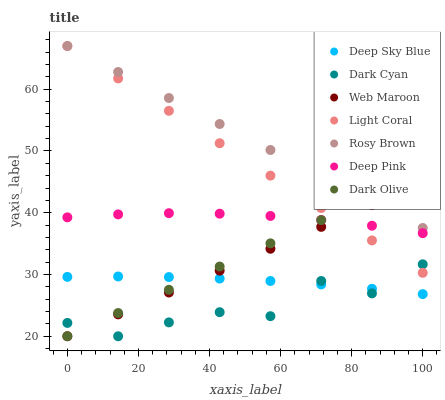Does Dark Cyan have the minimum area under the curve?
Answer yes or no. Yes. Does Rosy Brown have the maximum area under the curve?
Answer yes or no. Yes. Does Dark Olive have the minimum area under the curve?
Answer yes or no. No. Does Dark Olive have the maximum area under the curve?
Answer yes or no. No. Is Rosy Brown the smoothest?
Answer yes or no. Yes. Is Dark Cyan the roughest?
Answer yes or no. Yes. Is Dark Olive the smoothest?
Answer yes or no. No. Is Dark Olive the roughest?
Answer yes or no. No. Does Dark Olive have the lowest value?
Answer yes or no. Yes. Does Rosy Brown have the lowest value?
Answer yes or no. No. Does Light Coral have the highest value?
Answer yes or no. Yes. Does Dark Olive have the highest value?
Answer yes or no. No. Is Deep Sky Blue less than Deep Pink?
Answer yes or no. Yes. Is Deep Pink greater than Deep Sky Blue?
Answer yes or no. Yes. Does Web Maroon intersect Deep Pink?
Answer yes or no. Yes. Is Web Maroon less than Deep Pink?
Answer yes or no. No. Is Web Maroon greater than Deep Pink?
Answer yes or no. No. Does Deep Sky Blue intersect Deep Pink?
Answer yes or no. No. 